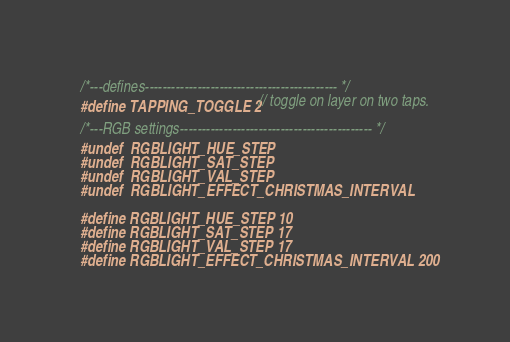Convert code to text. <code><loc_0><loc_0><loc_500><loc_500><_C_>/*---defines-------------------------------------------- */
#define TAPPING_TOGGLE 2 // toggle on layer on two taps.

/*---RGB settings-------------------------------------------- */
#undef  RGBLIGHT_HUE_STEP
#undef  RGBLIGHT_SAT_STEP
#undef  RGBLIGHT_VAL_STEP
#undef  RGBLIGHT_EFFECT_CHRISTMAS_INTERVAL

#define RGBLIGHT_HUE_STEP 10
#define RGBLIGHT_SAT_STEP 17
#define RGBLIGHT_VAL_STEP 17
#define RGBLIGHT_EFFECT_CHRISTMAS_INTERVAL 200</code> 